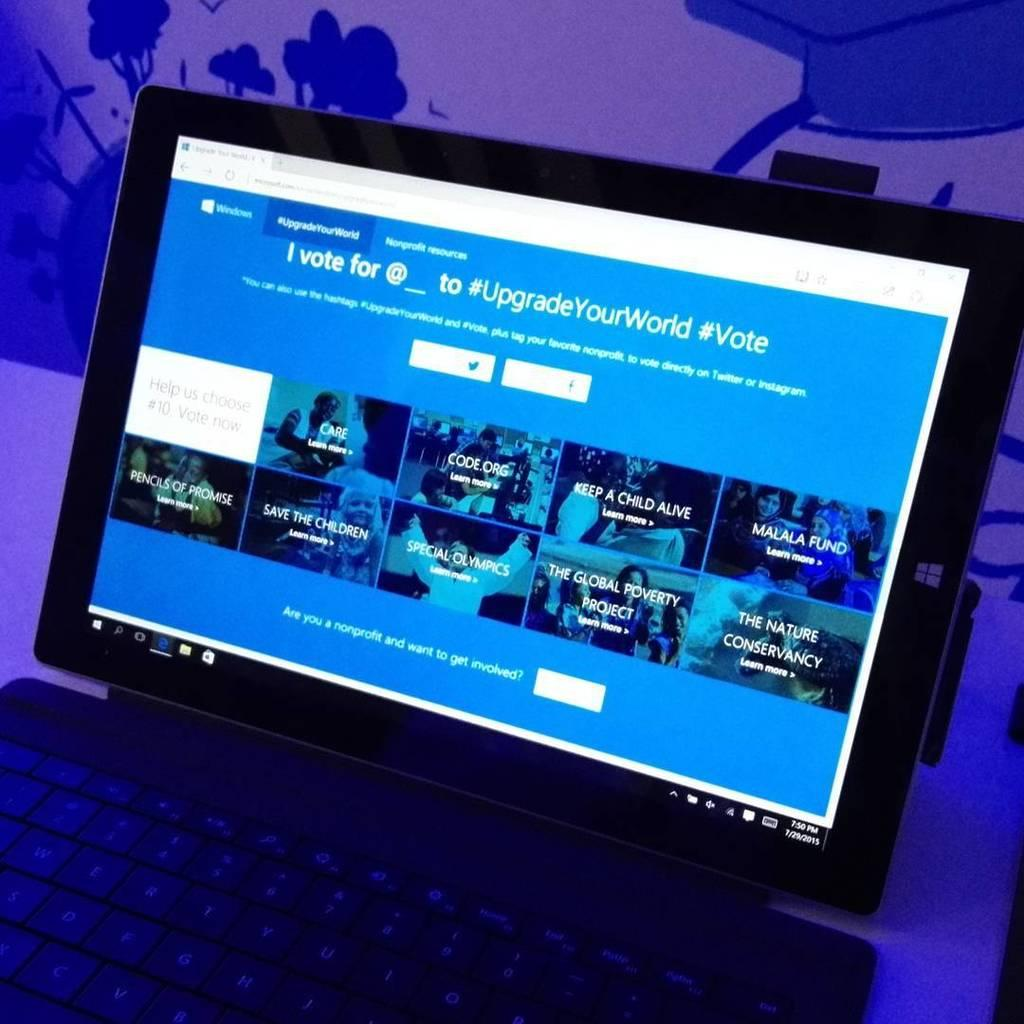Provide a one-sentence caption for the provided image. A laptop with the monitor opened to a webpage with the hashtag upgradeyourworld. 